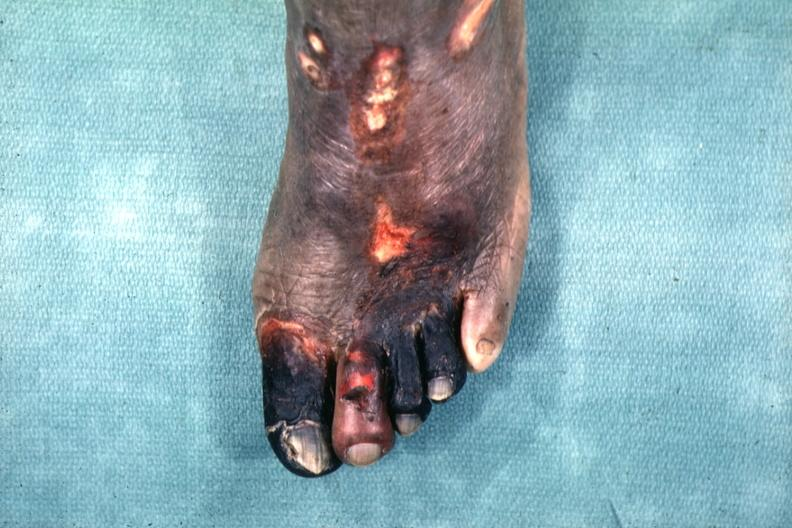re extremities present?
Answer the question using a single word or phrase. Yes 